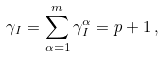Convert formula to latex. <formula><loc_0><loc_0><loc_500><loc_500>\gamma _ { I } = \sum _ { \alpha = 1 } ^ { m } \gamma _ { I } ^ { \alpha } = p + 1 \, ,</formula> 